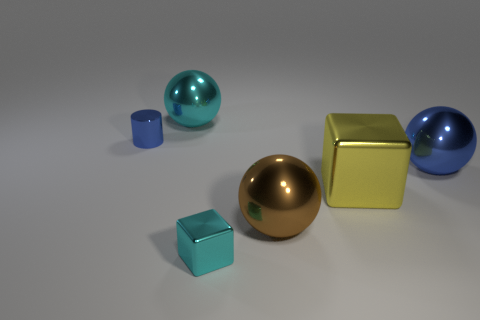Add 4 shiny balls. How many objects exist? 10 Subtract all cylinders. How many objects are left? 5 Subtract all large cubes. Subtract all blue shiny spheres. How many objects are left? 4 Add 2 brown metallic balls. How many brown metallic balls are left? 3 Add 4 small metallic objects. How many small metallic objects exist? 6 Subtract 1 yellow blocks. How many objects are left? 5 